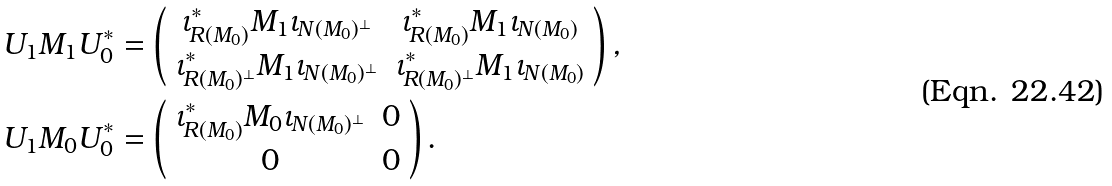Convert formula to latex. <formula><loc_0><loc_0><loc_500><loc_500>U _ { 1 } M _ { 1 } U _ { 0 } ^ { * } & = \left ( \begin{array} { c c } \iota _ { R ( M _ { 0 } ) } ^ { \ast } M _ { 1 } \iota _ { N ( M _ { 0 } ) ^ { \bot } } & \iota _ { R ( M _ { 0 } ) } ^ { \ast } M _ { 1 } \iota _ { N ( M _ { 0 } ) } \\ \iota _ { R ( M _ { 0 } ) ^ { \bot } } ^ { \ast } M _ { 1 } \iota _ { N ( M _ { 0 } ) ^ { \bot } } & \iota _ { R ( M _ { 0 } ) ^ { \bot } } ^ { \ast } M _ { 1 } \iota _ { N ( M _ { 0 } ) } \end{array} \right ) , \\ U _ { 1 } M _ { 0 } U _ { 0 } ^ { * } & = \left ( \begin{array} { c c } \iota _ { R ( M _ { 0 } ) } ^ { \ast } M _ { 0 } \iota _ { N ( M _ { 0 } ) ^ { \bot } } & 0 \\ 0 & 0 \end{array} \right ) .</formula> 